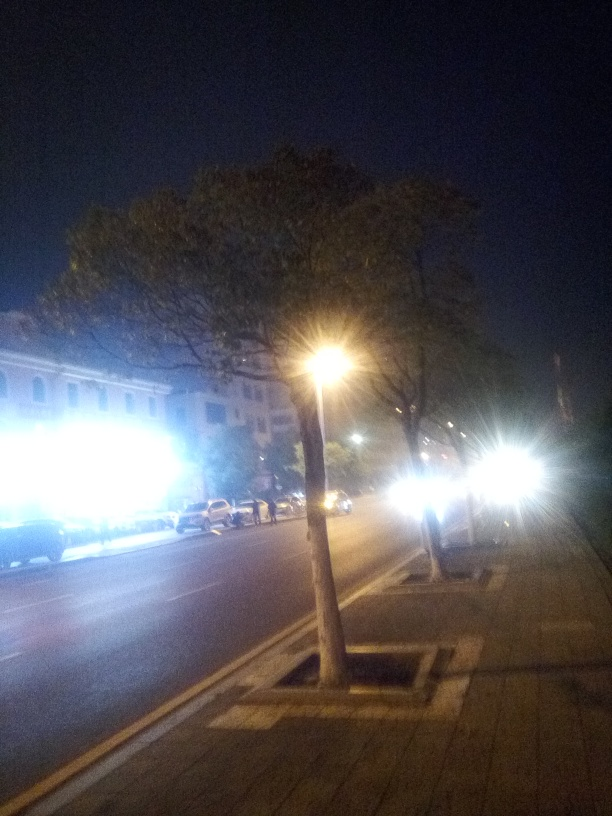Is the image free from quality issues? Upon review, the image exhibits several quality issues including noticeable blurriness, low lighting conditions, and possible camera shake or motion blur. These factors materially affect the clarity and detail of the photograph, making it challenging to discern finer details. 